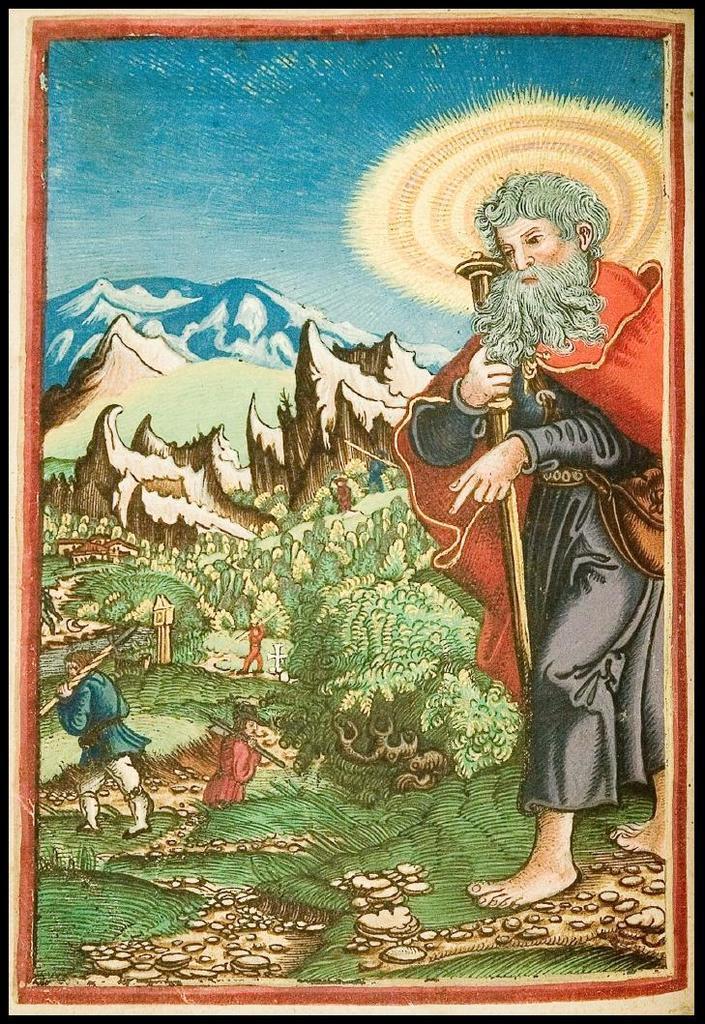How would you summarize this image in a sentence or two? In the picture there is a poster, on the poster we can see there are people, trees, mountains and a clear sky. 